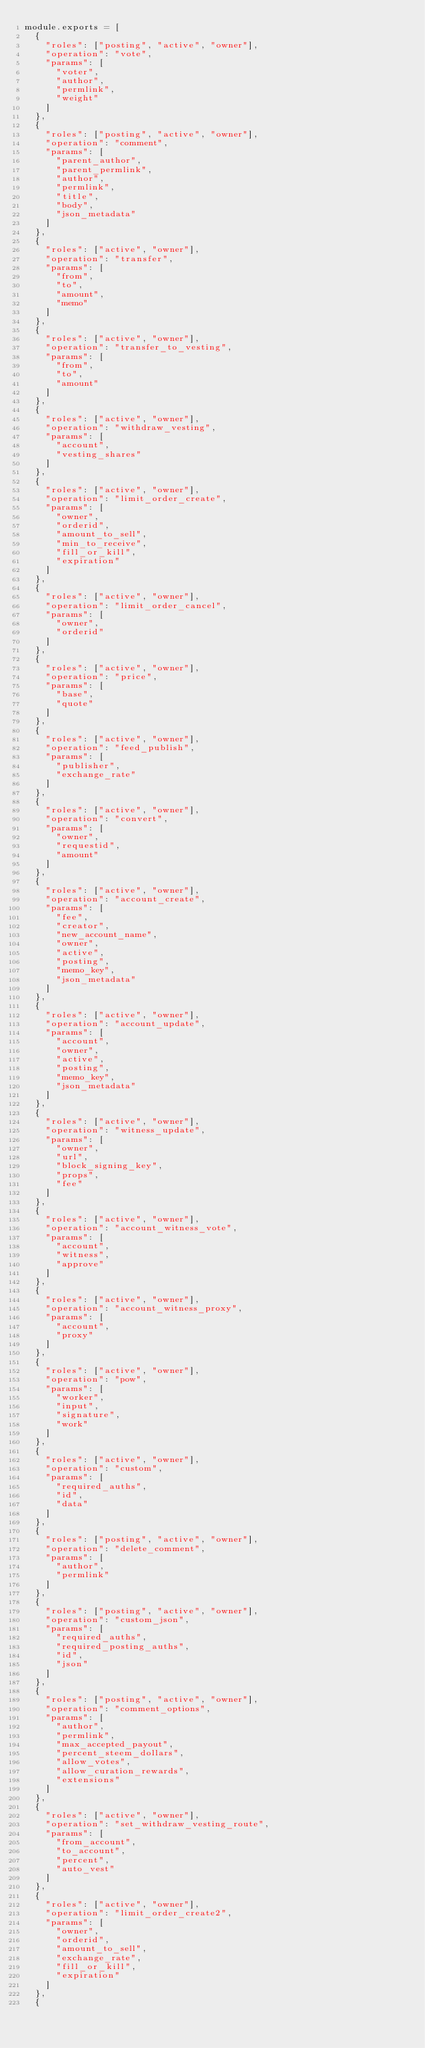<code> <loc_0><loc_0><loc_500><loc_500><_JavaScript_>module.exports = [
  {
    "roles": ["posting", "active", "owner"],
    "operation": "vote",
    "params": [
      "voter",
      "author",
      "permlink",
      "weight"
    ]
  },
  {
    "roles": ["posting", "active", "owner"],
    "operation": "comment",
    "params": [
      "parent_author",
      "parent_permlink",
      "author",
      "permlink",
      "title",
      "body",
      "json_metadata"
    ]
  },
  {
    "roles": ["active", "owner"],
    "operation": "transfer",
    "params": [
      "from",
      "to",
      "amount",
      "memo"
    ]
  },
  {
    "roles": ["active", "owner"],
    "operation": "transfer_to_vesting",
    "params": [
      "from",
      "to",
      "amount"
    ]
  },
  {
    "roles": ["active", "owner"],
    "operation": "withdraw_vesting",
    "params": [
      "account",
      "vesting_shares"
    ]
  },
  {
    "roles": ["active", "owner"],
    "operation": "limit_order_create",
    "params": [
      "owner",
      "orderid",
      "amount_to_sell",
      "min_to_receive",
      "fill_or_kill",
      "expiration"
    ]
  },
  {
    "roles": ["active", "owner"],
    "operation": "limit_order_cancel",
    "params": [
      "owner",
      "orderid"
    ]
  },
  {
    "roles": ["active", "owner"],
    "operation": "price",
    "params": [
      "base",
      "quote"
    ]
  },
  {
    "roles": ["active", "owner"],
    "operation": "feed_publish",
    "params": [
      "publisher",
      "exchange_rate"
    ]
  },
  {
    "roles": ["active", "owner"],
    "operation": "convert",
    "params": [
      "owner",
      "requestid",
      "amount"
    ]
  },
  {
    "roles": ["active", "owner"],
    "operation": "account_create",
    "params": [
      "fee",
      "creator",
      "new_account_name",
      "owner",
      "active",
      "posting",
      "memo_key",
      "json_metadata"
    ]
  },
  {
    "roles": ["active", "owner"],
    "operation": "account_update",
    "params": [
      "account",
      "owner",
      "active",
      "posting",
      "memo_key",
      "json_metadata"
    ]
  },
  {
    "roles": ["active", "owner"],
    "operation": "witness_update",
    "params": [
      "owner",
      "url",
      "block_signing_key",
      "props",
      "fee"
    ]
  },
  {
    "roles": ["active", "owner"],
    "operation": "account_witness_vote",
    "params": [
      "account",
      "witness",
      "approve"
    ]
  },
  {
    "roles": ["active", "owner"],
    "operation": "account_witness_proxy",
    "params": [
      "account",
      "proxy"
    ]
  },
  {
    "roles": ["active", "owner"],
    "operation": "pow",
    "params": [
      "worker",
      "input",
      "signature",
      "work"
    ]
  },
  {
    "roles": ["active", "owner"],
    "operation": "custom",
    "params": [
      "required_auths",
      "id",
      "data"
    ]
  },
  {
    "roles": ["posting", "active", "owner"],
    "operation": "delete_comment",
    "params": [
      "author",
      "permlink"
    ]
  },
  {
    "roles": ["posting", "active", "owner"],
    "operation": "custom_json",
    "params": [
      "required_auths",
      "required_posting_auths",
      "id",
      "json"
    ]
  },
  {
    "roles": ["posting", "active", "owner"],
    "operation": "comment_options",
    "params": [
      "author",
      "permlink",
      "max_accepted_payout",
      "percent_steem_dollars",
      "allow_votes",
      "allow_curation_rewards",
      "extensions"
    ]
  },
  {
    "roles": ["active", "owner"],
    "operation": "set_withdraw_vesting_route",
    "params": [
      "from_account",
      "to_account",
      "percent",
      "auto_vest"
    ]
  },
  {
    "roles": ["active", "owner"],
    "operation": "limit_order_create2",
    "params": [
      "owner",
      "orderid",
      "amount_to_sell",
      "exchange_rate",
      "fill_or_kill",
      "expiration"
    ]
  },
  {</code> 